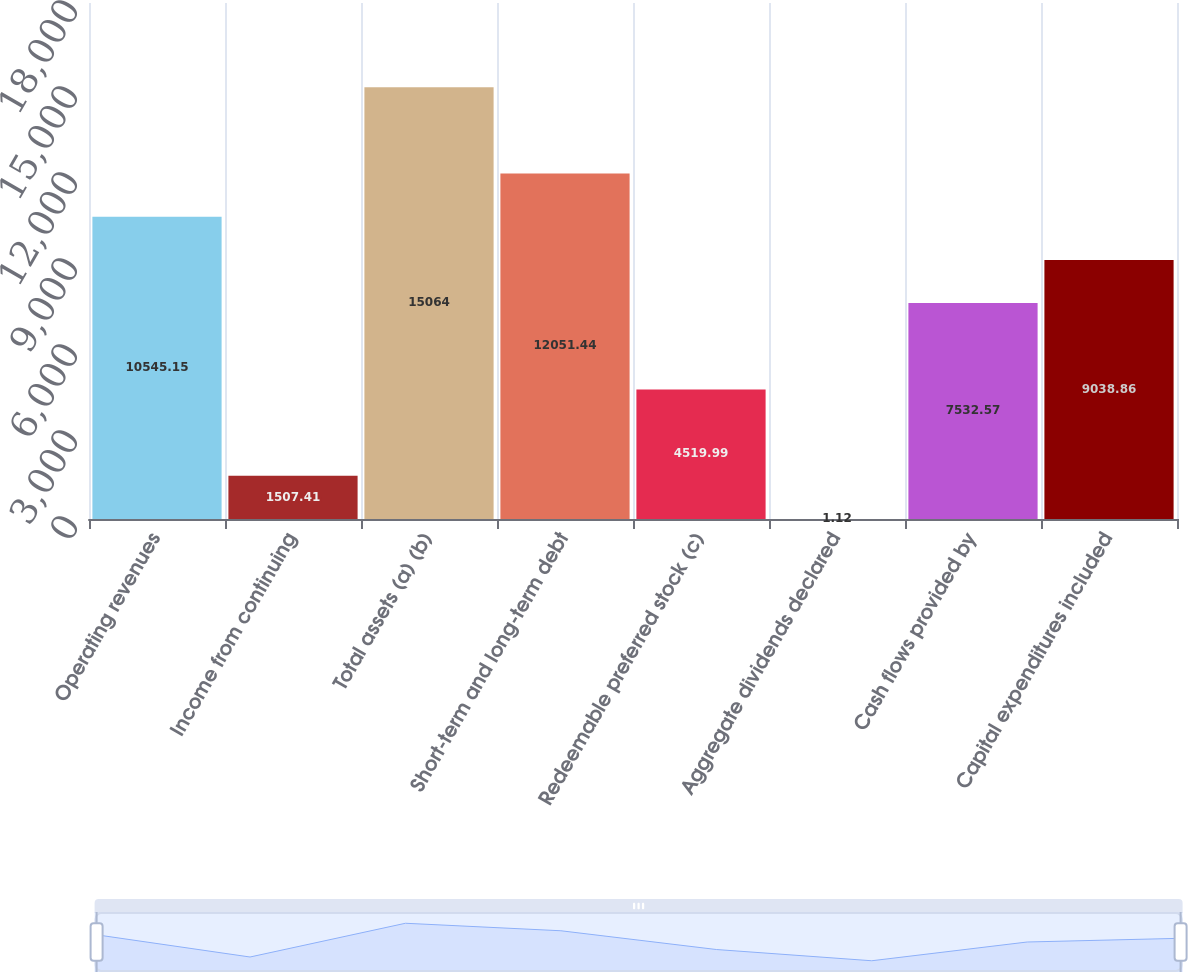<chart> <loc_0><loc_0><loc_500><loc_500><bar_chart><fcel>Operating revenues<fcel>Income from continuing<fcel>Total assets (a) (b)<fcel>Short-term and long-term debt<fcel>Redeemable preferred stock (c)<fcel>Aggregate dividends declared<fcel>Cash flows provided by<fcel>Capital expenditures included<nl><fcel>10545.1<fcel>1507.41<fcel>15064<fcel>12051.4<fcel>4519.99<fcel>1.12<fcel>7532.57<fcel>9038.86<nl></chart> 